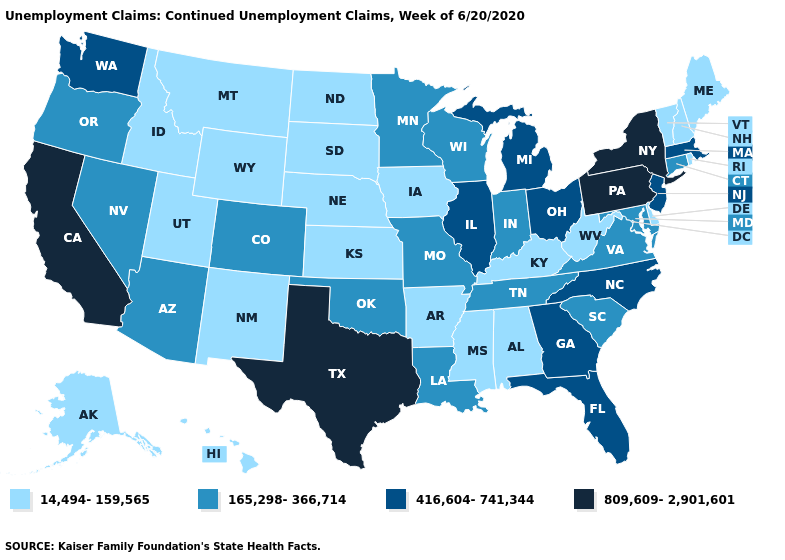Name the states that have a value in the range 416,604-741,344?
Be succinct. Florida, Georgia, Illinois, Massachusetts, Michigan, New Jersey, North Carolina, Ohio, Washington. Name the states that have a value in the range 416,604-741,344?
Concise answer only. Florida, Georgia, Illinois, Massachusetts, Michigan, New Jersey, North Carolina, Ohio, Washington. What is the lowest value in the USA?
Give a very brief answer. 14,494-159,565. Name the states that have a value in the range 809,609-2,901,601?
Short answer required. California, New York, Pennsylvania, Texas. Name the states that have a value in the range 809,609-2,901,601?
Short answer required. California, New York, Pennsylvania, Texas. Which states have the lowest value in the USA?
Short answer required. Alabama, Alaska, Arkansas, Delaware, Hawaii, Idaho, Iowa, Kansas, Kentucky, Maine, Mississippi, Montana, Nebraska, New Hampshire, New Mexico, North Dakota, Rhode Island, South Dakota, Utah, Vermont, West Virginia, Wyoming. What is the value of West Virginia?
Be succinct. 14,494-159,565. Does Vermont have the lowest value in the Northeast?
Keep it brief. Yes. What is the highest value in the Northeast ?
Answer briefly. 809,609-2,901,601. What is the value of Arkansas?
Quick response, please. 14,494-159,565. Does California have the same value as Pennsylvania?
Be succinct. Yes. Does the map have missing data?
Quick response, please. No. What is the value of Georgia?
Short answer required. 416,604-741,344. What is the value of Arizona?
Short answer required. 165,298-366,714. What is the lowest value in the USA?
Short answer required. 14,494-159,565. 